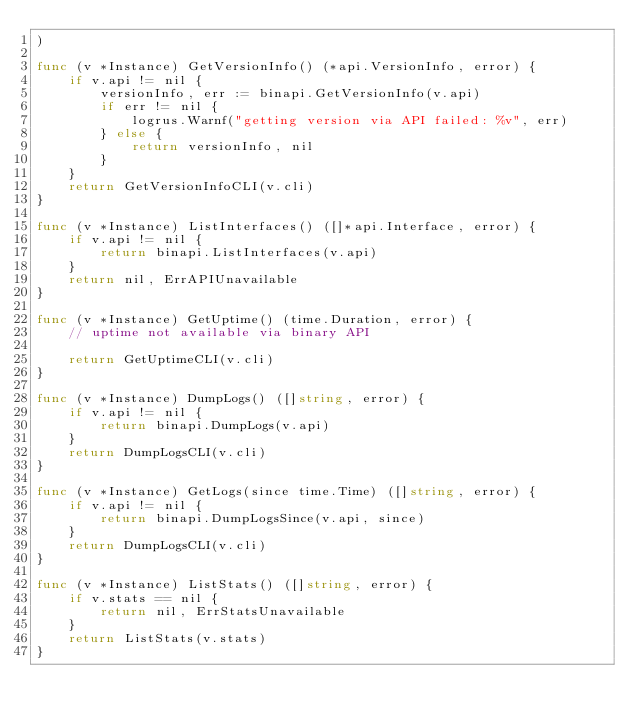<code> <loc_0><loc_0><loc_500><loc_500><_Go_>)

func (v *Instance) GetVersionInfo() (*api.VersionInfo, error) {
	if v.api != nil {
		versionInfo, err := binapi.GetVersionInfo(v.api)
		if err != nil {
			logrus.Warnf("getting version via API failed: %v", err)
		} else {
			return versionInfo, nil
		}
	}
	return GetVersionInfoCLI(v.cli)
}

func (v *Instance) ListInterfaces() ([]*api.Interface, error) {
	if v.api != nil {
		return binapi.ListInterfaces(v.api)
	}
	return nil, ErrAPIUnavailable
}

func (v *Instance) GetUptime() (time.Duration, error) {
	// uptime not available via binary API

	return GetUptimeCLI(v.cli)
}

func (v *Instance) DumpLogs() ([]string, error) {
	if v.api != nil {
		return binapi.DumpLogs(v.api)
	}
	return DumpLogsCLI(v.cli)
}

func (v *Instance) GetLogs(since time.Time) ([]string, error) {
	if v.api != nil {
		return binapi.DumpLogsSince(v.api, since)
	}
	return DumpLogsCLI(v.cli)
}

func (v *Instance) ListStats() ([]string, error) {
	if v.stats == nil {
		return nil, ErrStatsUnavailable
	}
	return ListStats(v.stats)
}
</code> 